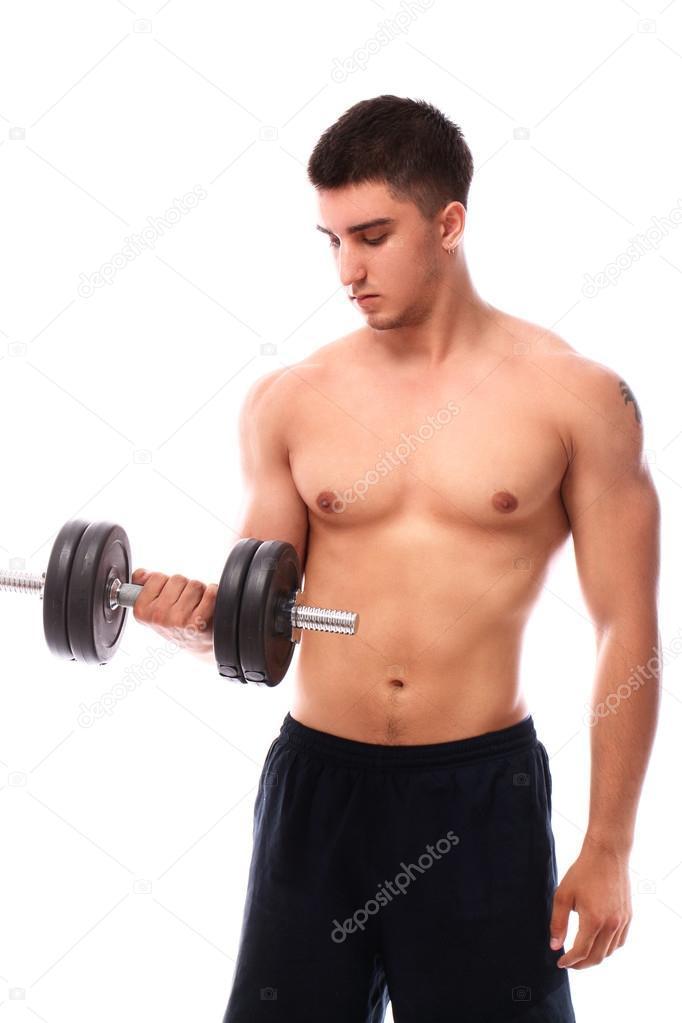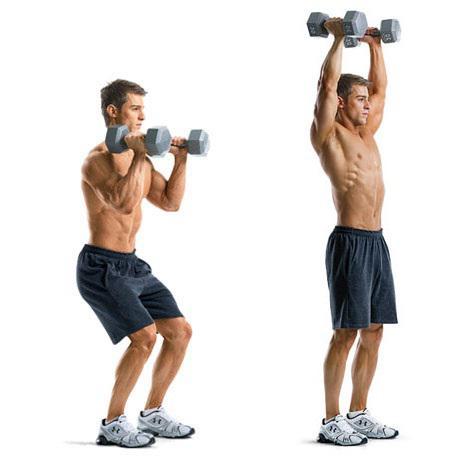The first image is the image on the left, the second image is the image on the right. Evaluate the accuracy of this statement regarding the images: "There are exactly two men in the image on the right.". Is it true? Answer yes or no. Yes. 